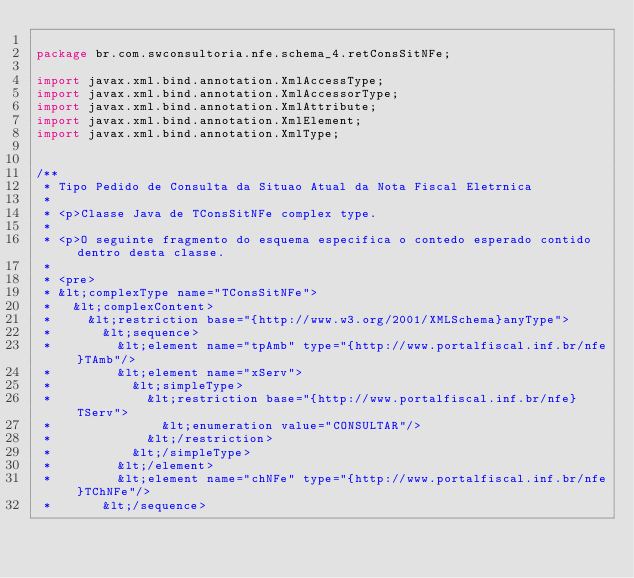Convert code to text. <code><loc_0><loc_0><loc_500><loc_500><_Java_>
package br.com.swconsultoria.nfe.schema_4.retConsSitNFe;

import javax.xml.bind.annotation.XmlAccessType;
import javax.xml.bind.annotation.XmlAccessorType;
import javax.xml.bind.annotation.XmlAttribute;
import javax.xml.bind.annotation.XmlElement;
import javax.xml.bind.annotation.XmlType;


/**
 * Tipo Pedido de Consulta da Situao Atual da Nota Fiscal Eletrnica
 * 
 * <p>Classe Java de TConsSitNFe complex type.
 * 
 * <p>O seguinte fragmento do esquema especifica o contedo esperado contido dentro desta classe.
 * 
 * <pre>
 * &lt;complexType name="TConsSitNFe">
 *   &lt;complexContent>
 *     &lt;restriction base="{http://www.w3.org/2001/XMLSchema}anyType">
 *       &lt;sequence>
 *         &lt;element name="tpAmb" type="{http://www.portalfiscal.inf.br/nfe}TAmb"/>
 *         &lt;element name="xServ">
 *           &lt;simpleType>
 *             &lt;restriction base="{http://www.portalfiscal.inf.br/nfe}TServ">
 *               &lt;enumeration value="CONSULTAR"/>
 *             &lt;/restriction>
 *           &lt;/simpleType>
 *         &lt;/element>
 *         &lt;element name="chNFe" type="{http://www.portalfiscal.inf.br/nfe}TChNFe"/>
 *       &lt;/sequence></code> 